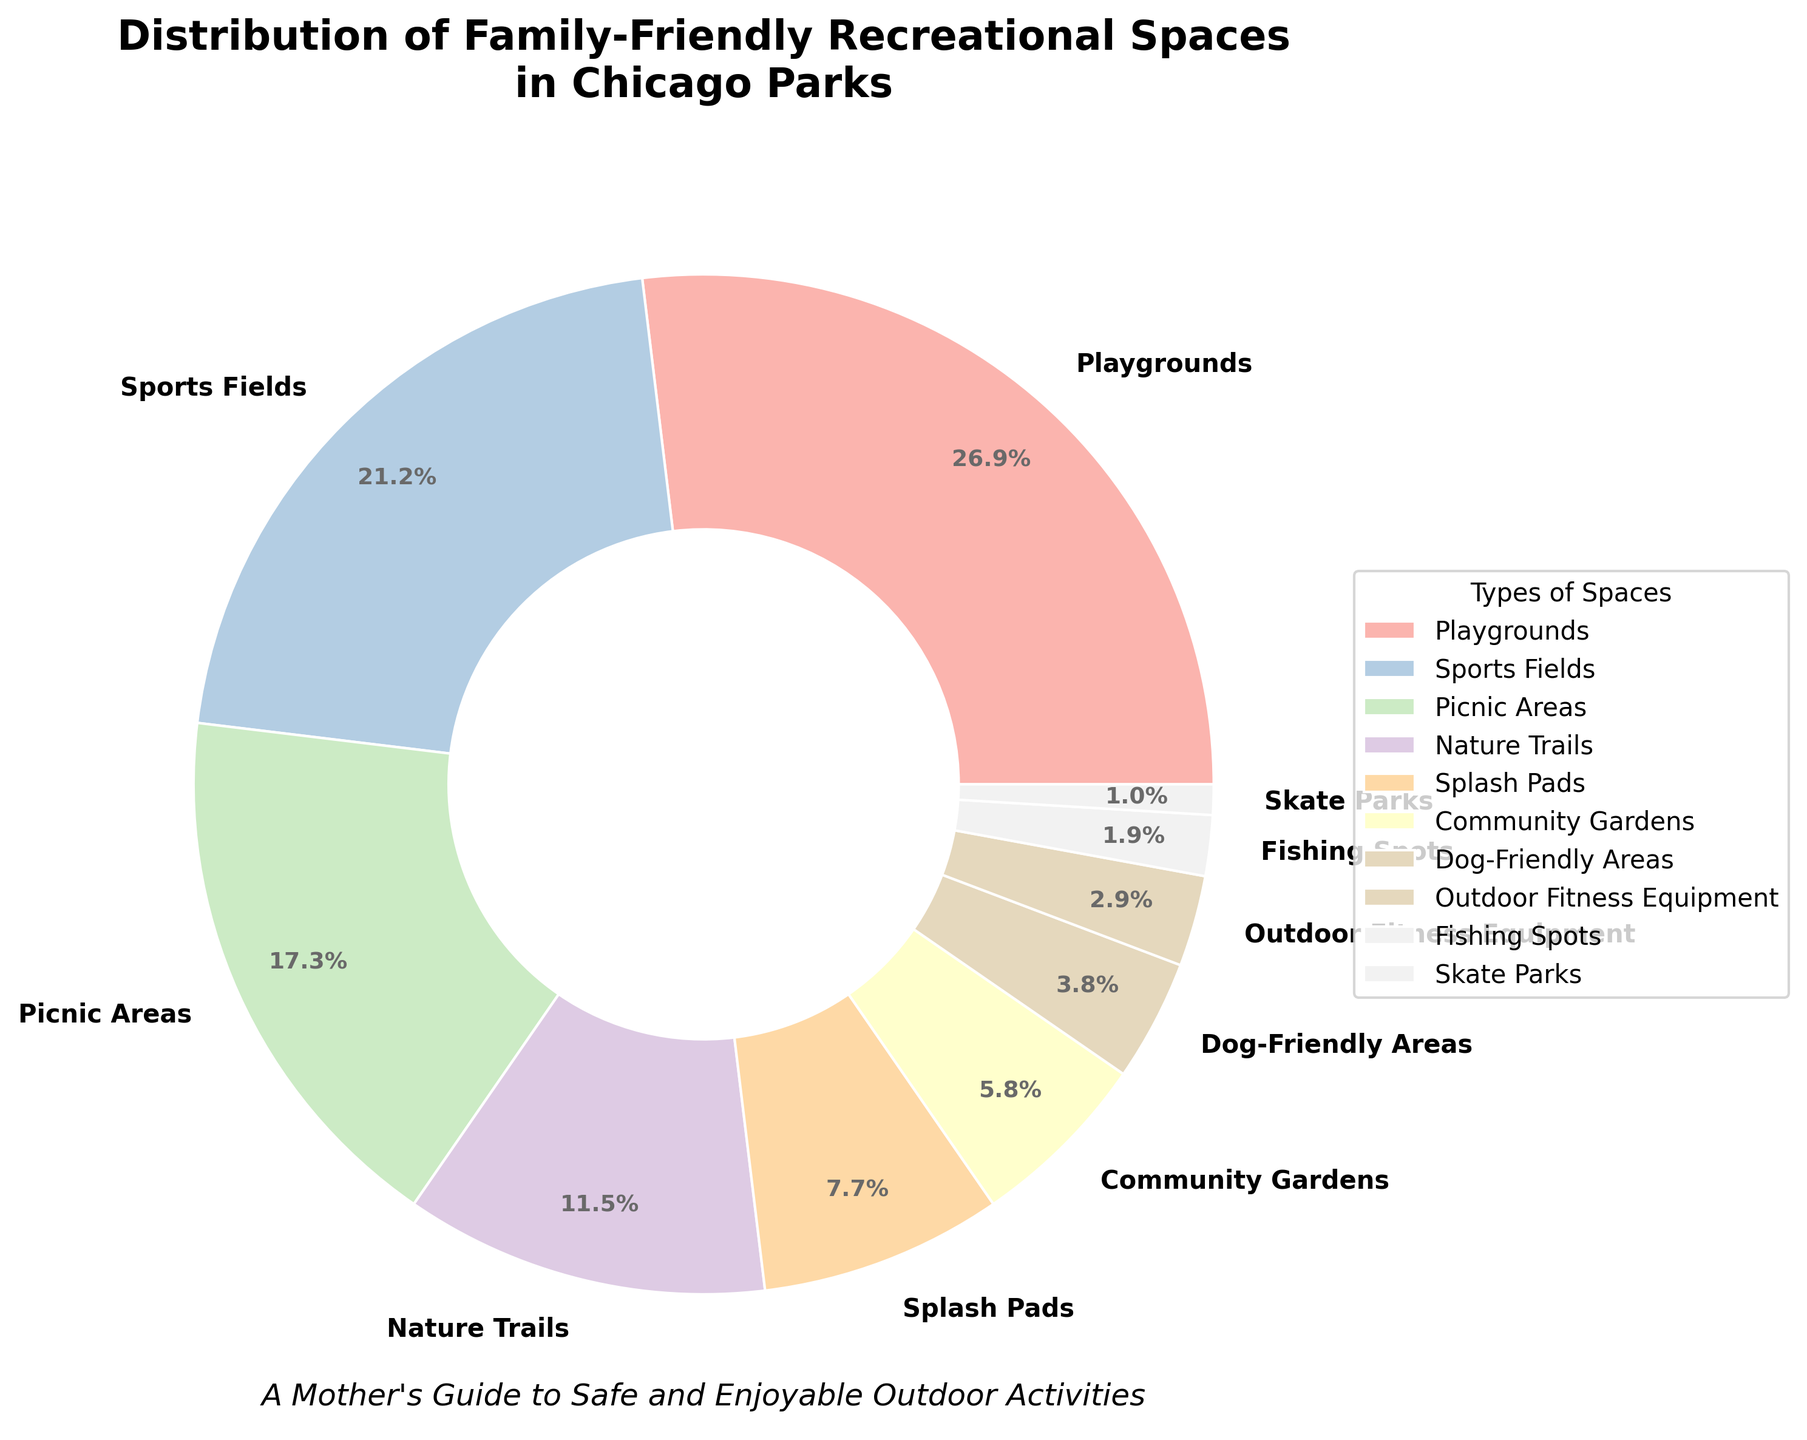Which type of family-friendly space takes up the largest percentage in Chicago parks? Look at the pie slices and labels to identify which type has the largest share. The slice labeled 'Playgrounds' is the largest at 28%.
Answer: Playgrounds How much larger is the percentage of Splash Pads compared to Skate Parks? Identify the percentages for Splash Pads (8%) and Skate Parks (1%), and find the difference: 8% - 1% = 7%.
Answer: 7% What is the combined percentage of Picnic Areas and Nature Trails? Identify the percentages for Picnic Areas (18%) and Nature Trails (12%), then add them together: 18% + 12% = 30%.
Answer: 30% Are there more Playgrounds or Sports Fields in Chicago parks? Compare the percentages for Playgrounds (28%) and Sports Fields (22%). Playgrounds have a larger percentage.
Answer: Playgrounds Which space constitutes a smaller percentage: Dog-Friendly Areas or Outdoor Fitness Equipment? Compare the percentages for Dog-Friendly Areas (4%) and Outdoor Fitness Equipment (3%). Outdoor Fitness Equipment has a smaller percentage.
Answer: Outdoor Fitness Equipment Rank the top three types of family-friendly spaces by percentage. Identify the three largest percentages: Playgrounds (28%), Sports Fields (22%), and Picnic Areas (18%). Rank them from highest to lowest: Playgrounds, Sports Fields, Picnic Areas.
Answer: Playgrounds, Sports Fields, Picnic Areas If community gardens and fishing spots are combined, what would their total percentage be? Identify the percentages for Community Gardens (6%) and Fishing Spots (2%), then add them together: 6% + 2% = 8%.
Answer: 8% Which type of space has a percentage lower than 5%? Identify the spaces with percentages lower than 5%: Dog-Friendly Areas (4%), Outdoor Fitness Equipment (3%), Fishing Spots (2%), and Skate Parks (1%).
Answer: Dog-Friendly Areas, Outdoor Fitness Equipment, Fishing Spots, Skate Parks What is the difference in percentage between Nature Trails and Splash Pads? Identify the percentages for Nature Trails (12%) and Splash Pads (8%), then find the difference: 12% - 8% = 4%.
Answer: 4% Is the percentage of Nature Trails higher than the combined percentage of Community Gardens and Dog-Friendly Areas? Identify the percentages for Nature Trails (12%), Community Gardens (6%), and Dog-Friendly Areas (4%). The combined percentage of Community Gardens and Dog-Friendly Areas is 6% + 4% = 10%, which is less than Nature Trails' 12%.
Answer: Yes 